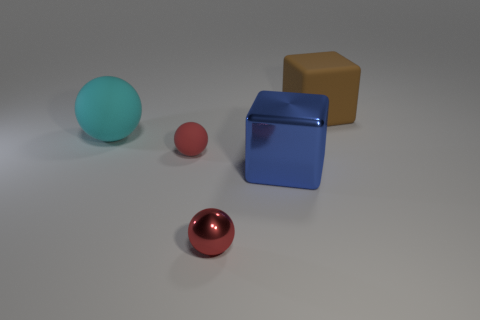How many other things are there of the same color as the shiny ball?
Ensure brevity in your answer.  1. What number of other things are the same shape as the small matte thing?
Your answer should be compact. 2. There is a object to the right of the blue cube; is it the same shape as the tiny object left of the tiny metallic sphere?
Provide a short and direct response. No. Is the number of small red matte balls that are in front of the brown thing the same as the number of rubber balls in front of the blue metallic object?
Ensure brevity in your answer.  No. What shape is the rubber object that is to the left of the matte ball that is in front of the big matte thing to the left of the matte block?
Provide a succinct answer. Sphere. Does the big cube that is in front of the large brown block have the same material as the tiny ball behind the tiny shiny ball?
Provide a succinct answer. No. There is a matte thing that is on the right side of the blue thing; what is its shape?
Provide a succinct answer. Cube. Are there fewer big blue metal cylinders than red metallic things?
Your answer should be compact. Yes. Are there any big balls that are to the right of the object to the left of the small red object behind the large blue metal cube?
Offer a very short reply. No. How many matte things are either large things or big cyan objects?
Your answer should be compact. 2. 